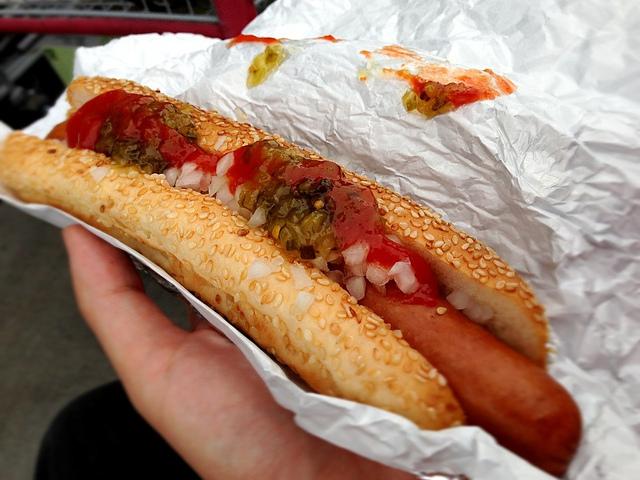How long is this hot dog?
Answer briefly. Footlong. Is there mustard?
Give a very brief answer. No. Is this food tasty?
Write a very short answer. Yes. What is on the bun?
Answer briefly. Hot dog. What vegetables are represented on this hot dog?
Answer briefly. Onions. 